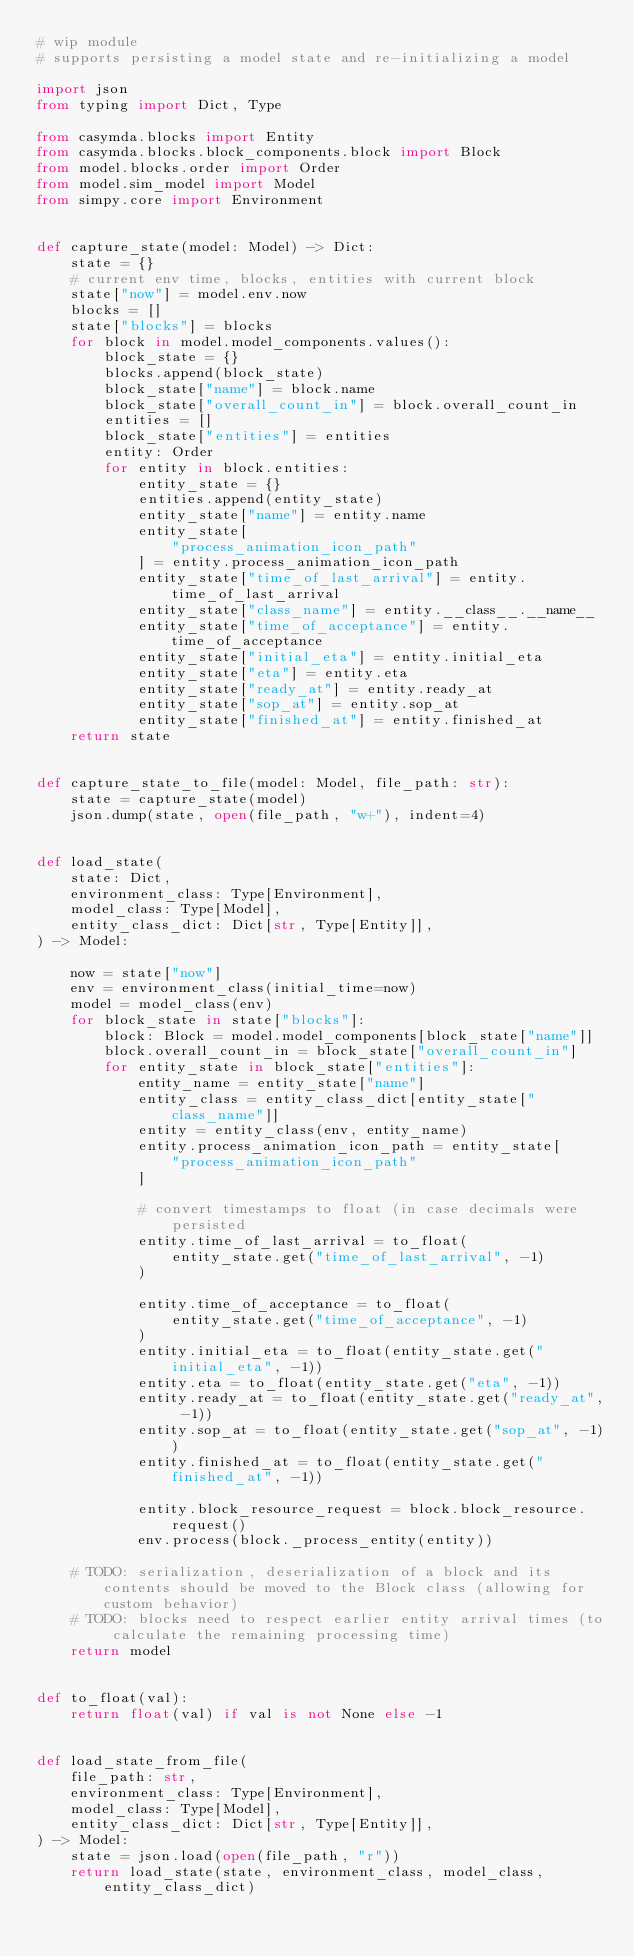<code> <loc_0><loc_0><loc_500><loc_500><_Python_># wip module
# supports persisting a model state and re-initializing a model

import json
from typing import Dict, Type

from casymda.blocks import Entity
from casymda.blocks.block_components.block import Block
from model.blocks.order import Order
from model.sim_model import Model
from simpy.core import Environment


def capture_state(model: Model) -> Dict:
    state = {}
    # current env time, blocks, entities with current block
    state["now"] = model.env.now
    blocks = []
    state["blocks"] = blocks
    for block in model.model_components.values():
        block_state = {}
        blocks.append(block_state)
        block_state["name"] = block.name
        block_state["overall_count_in"] = block.overall_count_in
        entities = []
        block_state["entities"] = entities
        entity: Order
        for entity in block.entities:
            entity_state = {}
            entities.append(entity_state)
            entity_state["name"] = entity.name
            entity_state[
                "process_animation_icon_path"
            ] = entity.process_animation_icon_path
            entity_state["time_of_last_arrival"] = entity.time_of_last_arrival
            entity_state["class_name"] = entity.__class__.__name__
            entity_state["time_of_acceptance"] = entity.time_of_acceptance
            entity_state["initial_eta"] = entity.initial_eta
            entity_state["eta"] = entity.eta
            entity_state["ready_at"] = entity.ready_at
            entity_state["sop_at"] = entity.sop_at
            entity_state["finished_at"] = entity.finished_at
    return state


def capture_state_to_file(model: Model, file_path: str):
    state = capture_state(model)
    json.dump(state, open(file_path, "w+"), indent=4)


def load_state(
    state: Dict,
    environment_class: Type[Environment],
    model_class: Type[Model],
    entity_class_dict: Dict[str, Type[Entity]],
) -> Model:

    now = state["now"]
    env = environment_class(initial_time=now)
    model = model_class(env)
    for block_state in state["blocks"]:
        block: Block = model.model_components[block_state["name"]]
        block.overall_count_in = block_state["overall_count_in"]
        for entity_state in block_state["entities"]:
            entity_name = entity_state["name"]
            entity_class = entity_class_dict[entity_state["class_name"]]
            entity = entity_class(env, entity_name)
            entity.process_animation_icon_path = entity_state[
                "process_animation_icon_path"
            ]

            # convert timestamps to float (in case decimals were persisted
            entity.time_of_last_arrival = to_float(
                entity_state.get("time_of_last_arrival", -1)
            )

            entity.time_of_acceptance = to_float(
                entity_state.get("time_of_acceptance", -1)
            )
            entity.initial_eta = to_float(entity_state.get("initial_eta", -1))
            entity.eta = to_float(entity_state.get("eta", -1))
            entity.ready_at = to_float(entity_state.get("ready_at", -1))
            entity.sop_at = to_float(entity_state.get("sop_at", -1))
            entity.finished_at = to_float(entity_state.get("finished_at", -1))

            entity.block_resource_request = block.block_resource.request()
            env.process(block._process_entity(entity))

    # TODO: serialization, deserialization of a block and its contents should be moved to the Block class (allowing for custom behavior)
    # TODO: blocks need to respect earlier entity arrival times (to calculate the remaining processing time)
    return model


def to_float(val):
    return float(val) if val is not None else -1


def load_state_from_file(
    file_path: str,
    environment_class: Type[Environment],
    model_class: Type[Model],
    entity_class_dict: Dict[str, Type[Entity]],
) -> Model:
    state = json.load(open(file_path, "r"))
    return load_state(state, environment_class, model_class, entity_class_dict)
</code> 